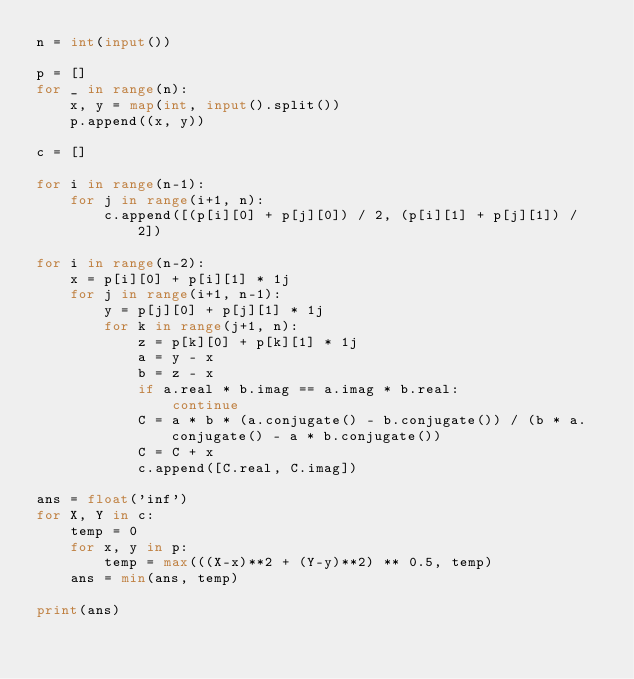Convert code to text. <code><loc_0><loc_0><loc_500><loc_500><_Python_>n = int(input())

p = []
for _ in range(n):
    x, y = map(int, input().split())
    p.append((x, y))

c = []

for i in range(n-1):
    for j in range(i+1, n):
        c.append([(p[i][0] + p[j][0]) / 2, (p[i][1] + p[j][1]) / 2])

for i in range(n-2):
    x = p[i][0] + p[i][1] * 1j
    for j in range(i+1, n-1):
        y = p[j][0] + p[j][1] * 1j
        for k in range(j+1, n):
            z = p[k][0] + p[k][1] * 1j
            a = y - x
            b = z - x
            if a.real * b.imag == a.imag * b.real:
                continue
            C = a * b * (a.conjugate() - b.conjugate()) / (b * a.conjugate() - a * b.conjugate())
            C = C + x
            c.append([C.real, C.imag])

ans = float('inf')
for X, Y in c:
    temp = 0
    for x, y in p:
        temp = max(((X-x)**2 + (Y-y)**2) ** 0.5, temp)
    ans = min(ans, temp)

print(ans)</code> 